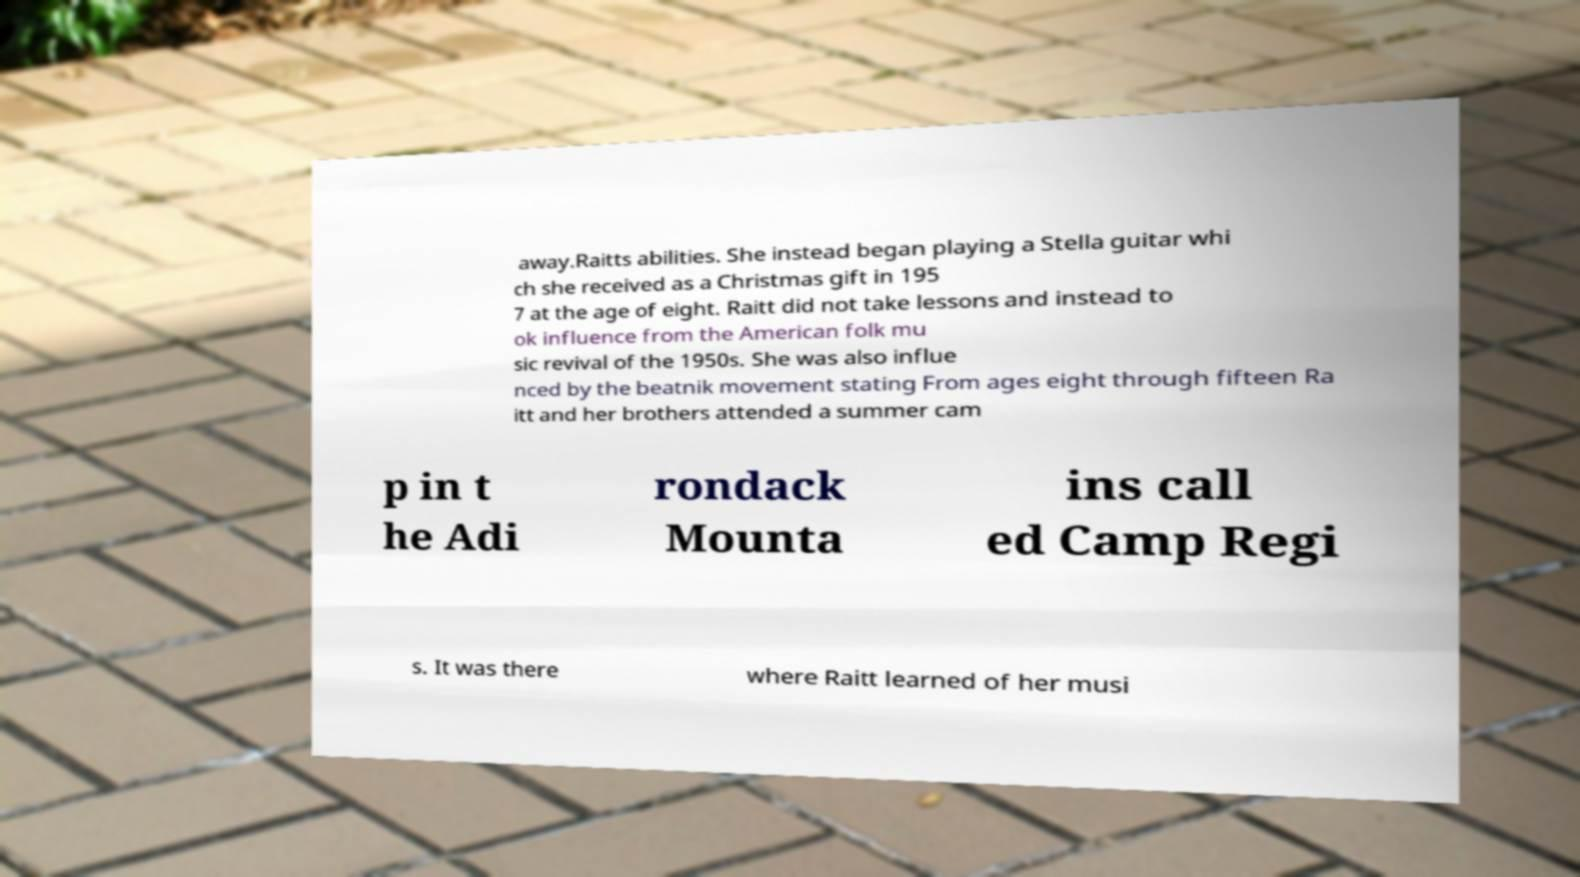Can you accurately transcribe the text from the provided image for me? away.Raitts abilities. She instead began playing a Stella guitar whi ch she received as a Christmas gift in 195 7 at the age of eight. Raitt did not take lessons and instead to ok influence from the American folk mu sic revival of the 1950s. She was also influe nced by the beatnik movement stating From ages eight through fifteen Ra itt and her brothers attended a summer cam p in t he Adi rondack Mounta ins call ed Camp Regi s. It was there where Raitt learned of her musi 